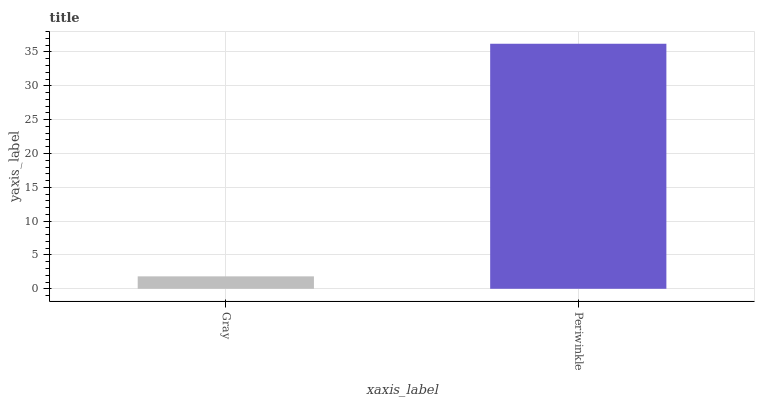Is Gray the minimum?
Answer yes or no. Yes. Is Periwinkle the maximum?
Answer yes or no. Yes. Is Periwinkle the minimum?
Answer yes or no. No. Is Periwinkle greater than Gray?
Answer yes or no. Yes. Is Gray less than Periwinkle?
Answer yes or no. Yes. Is Gray greater than Periwinkle?
Answer yes or no. No. Is Periwinkle less than Gray?
Answer yes or no. No. Is Periwinkle the high median?
Answer yes or no. Yes. Is Gray the low median?
Answer yes or no. Yes. Is Gray the high median?
Answer yes or no. No. Is Periwinkle the low median?
Answer yes or no. No. 